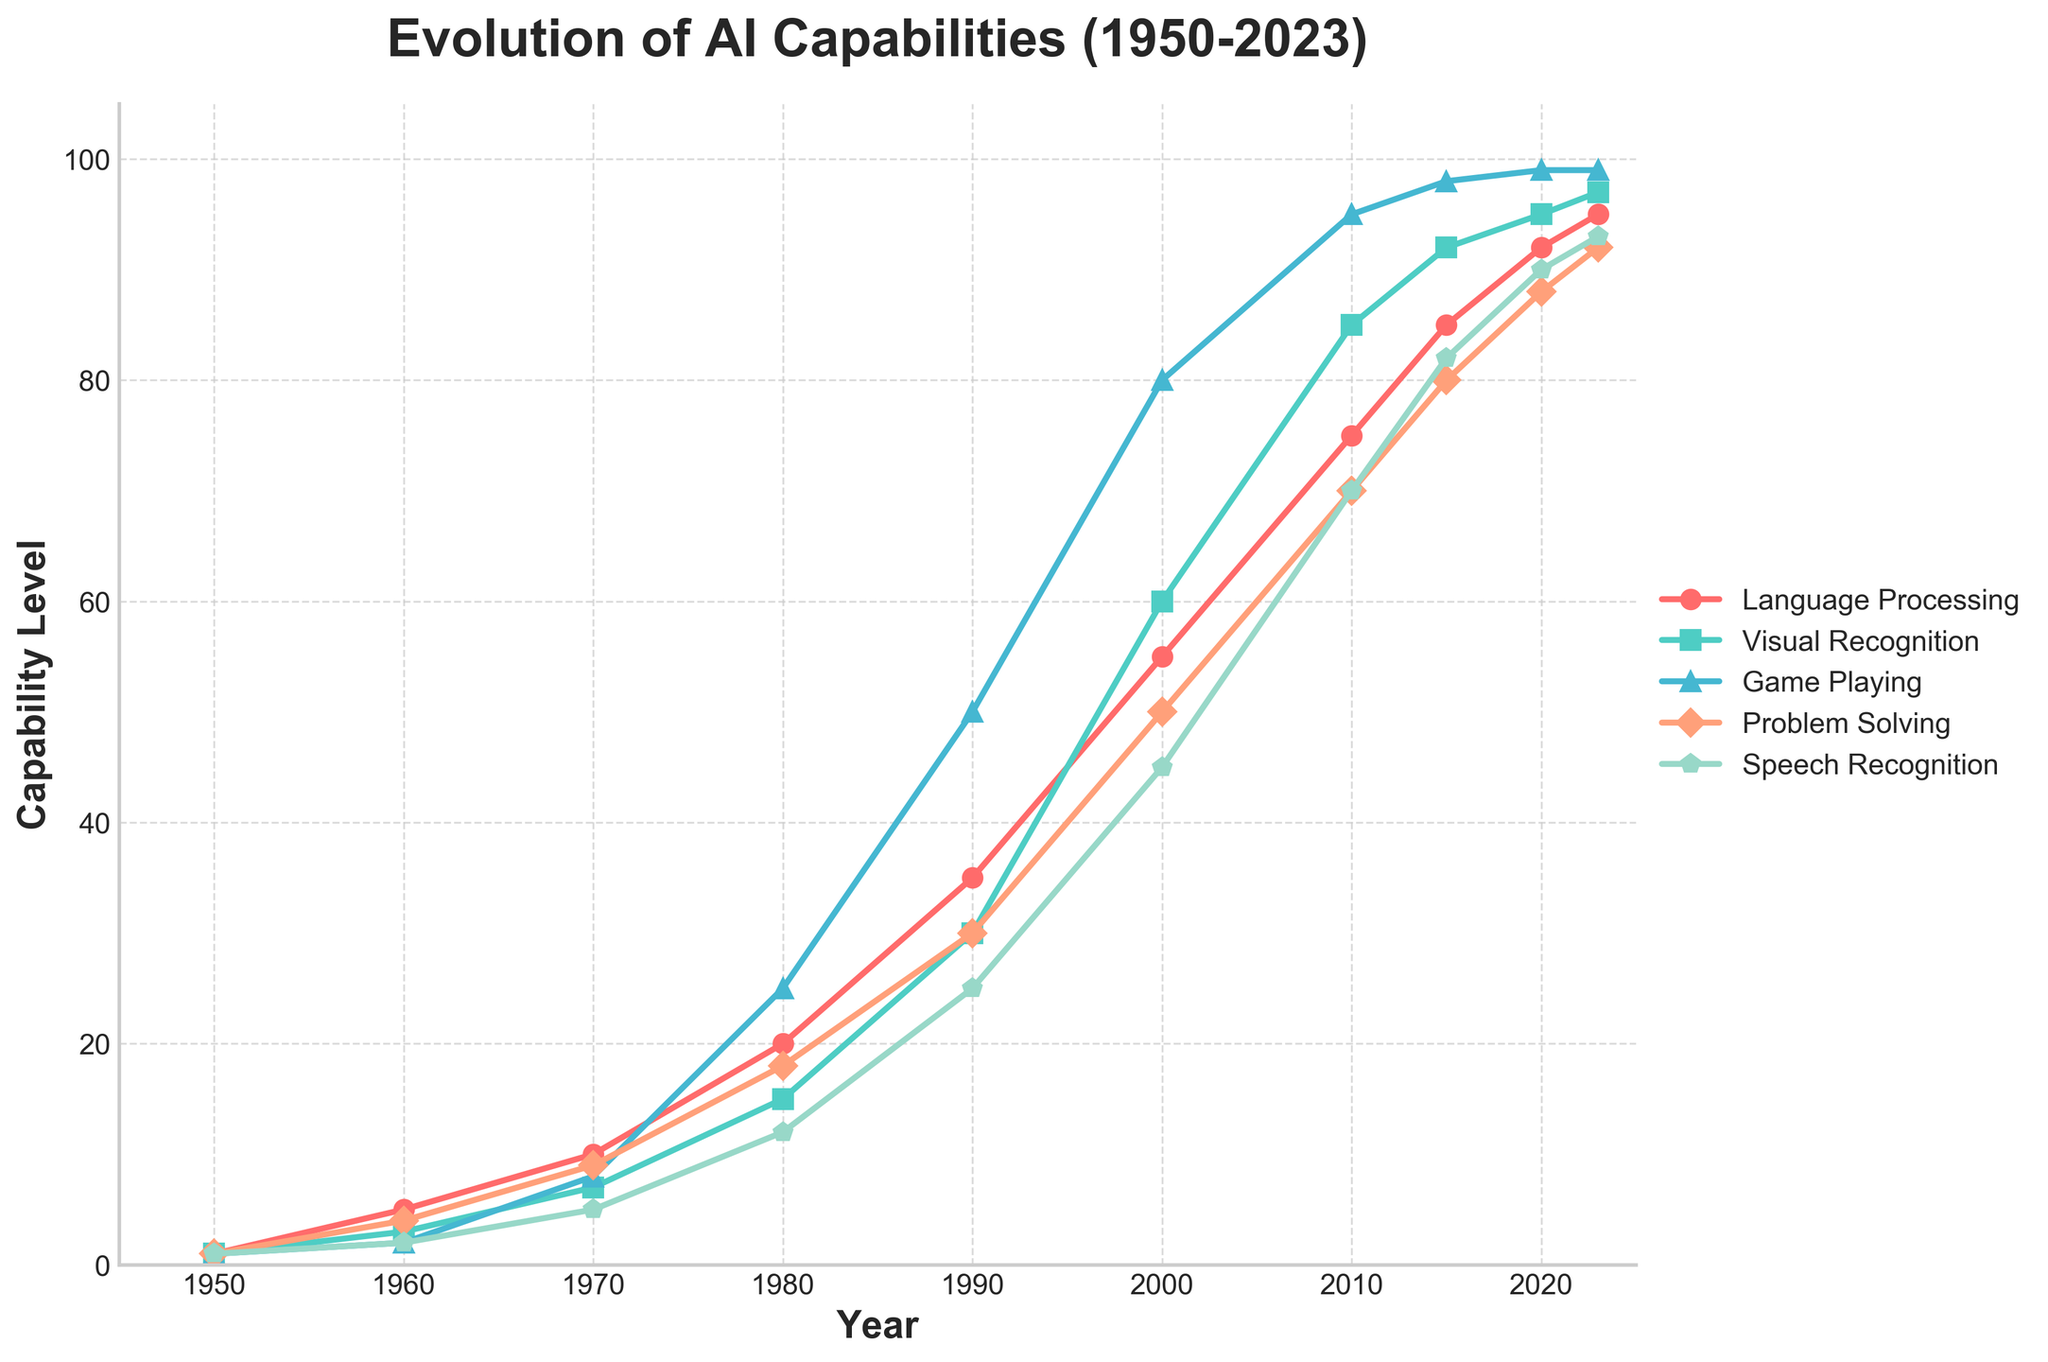What is the overall trend for AI capabilities in Language Processing from 1950 to 2023? The trend for AI capabilities in Language Processing shows a general upward trajectory from 1 in 1950 to 95 in 2023, indicating steady improvement over time.
Answer: Steady increase Between Speech Recognition and Visual Recognition, which capability reached a level of 80 first and in which year? By analyzing the data points in the figure, Speech Recognition reaches a level of 80 in 2015, while Visual Recognition hits this milestone earlier in 2000.
Answer: Visual Recognition, 2000 In the year 1990, how much more advanced was AI in Game Playing compared to Problem Solving? In 1990, Game Playing capability was at 50 while Problem Solving was at 30. The difference is calculated as 50 - 30, which is 20.
Answer: 20 What's the average capability level for Language Processing, Visual Recognition, and Game Playing in 2010? To find the average, add the capability levels for Language Processing (75), Visual Recognition (85), and Game Playing (95) in 2010 and divide by 3: (75 + 85 + 95) / 3 = 85.
Answer: 85 Which cognitive task had the most significant relative improvement from 1950 to 2023? By comparing the initial and final values, Game Playing shows the most substantial improvement, going from 1 in 1950 to 99 in 2023, a difference of 98 units.
Answer: Game Playing What is the capability level for Speech Recognition in the year 2000, and how does it compare with Game Playing in the same year? In 2000, the capability level for Speech Recognition is 45, whereas for Game Playing it is 80, with Game Playing being more advanced by 35 units.
Answer: Speech Recognition is 45, Game Playing is higher by 35 Between 2015 and 2020, which cognitive tasks show the greatest increments in their capability levels? By examining the increments, Language Processing increased from 85 to 92 (7 units), Visual Recognition from 92 to 95 (3 units), Game Playing from 98 to 99 (1 unit), Problem Solving from 80 to 88 (8 units), and Speech Recognition from 82 to 90 (8 units). Problem Solving and Speech Recognition both increased by 8 units.
Answer: Problem Solving and Speech Recognition In what years do Speech Recognition and Language Processing have the same capability level, if at all? By examining the data points, Speech Recognition and Language Processing have the same capability level of 93 in 2023.
Answer: 2023 How does the capability trend of Problem Solving compare visually with that of Visual Recognition? Both tasks show a continuous improvement trend, but Visual Recognition tends to increase faster than Problem Solving throughout most of the years. By 2023, both have high levels, though Visual Recognition is slightly higher.
Answer: Visual Recognition increases faster Which task saw the earliest rapid increase in capability, and during which decade did this primarily occur? The figure shows that Visual Recognition experienced a rapid increase starting in the 1980s, where the capability jumped significantly from 15 to 30 within a decade.
Answer: Visual Recognition, 1980s 